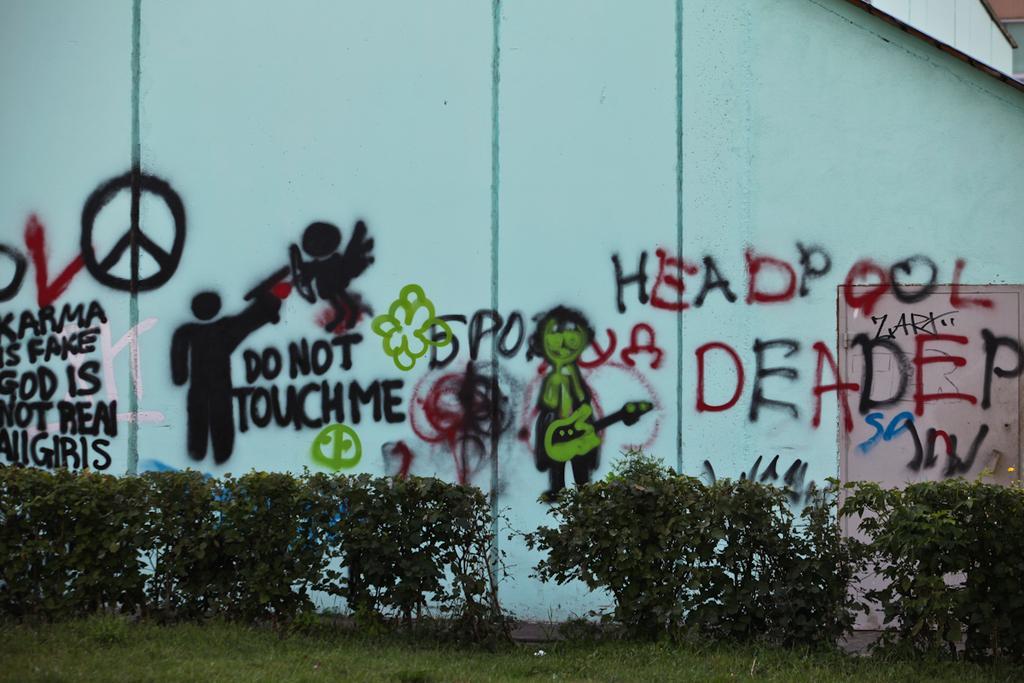How would you summarize this image in a sentence or two? In this picture we can see few arts on the wall, beside the wall we can see few shrubs and grass. 